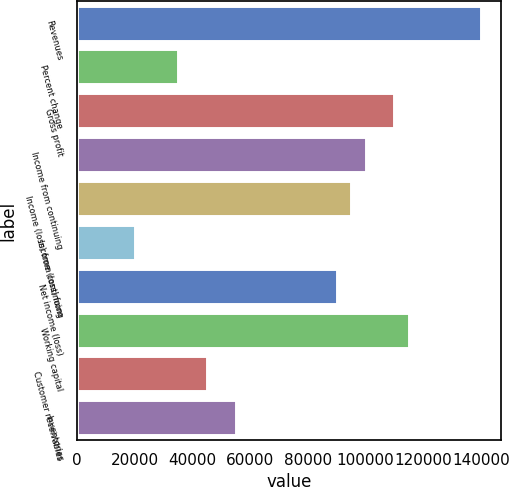Convert chart. <chart><loc_0><loc_0><loc_500><loc_500><bar_chart><fcel>Revenues<fcel>Percent change<fcel>Gross profit<fcel>Income from continuing<fcel>Income (loss) from continuing<fcel>Income (loss) from<fcel>Net income (loss)<fcel>Working capital<fcel>Customer receivables<fcel>Inventories<nl><fcel>139967<fcel>34991.7<fcel>109974<fcel>99976.2<fcel>94977.4<fcel>19995.2<fcel>89978.6<fcel>114973<fcel>44989.3<fcel>54986.9<nl></chart> 